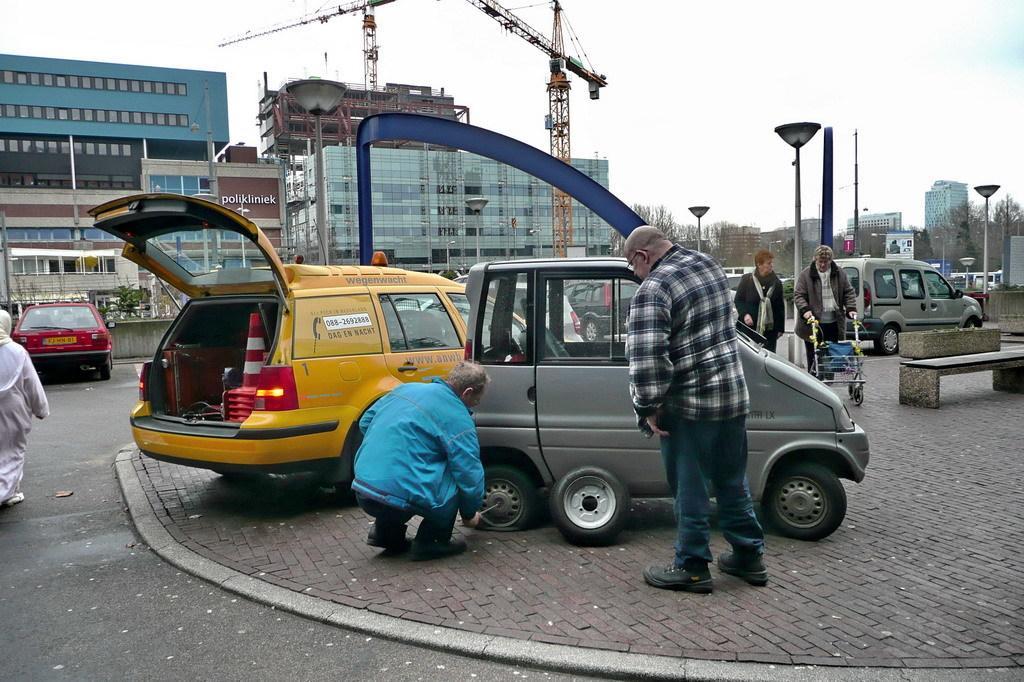In one or two sentences, can you explain what this image depicts? In this picture we can see group of people and few vehicles, in the middle of the image we can see a man, he is trying to change the car wheel, in the background we can see few buildings, poles, trees, hoardings and cranes, and also we can see lights. 